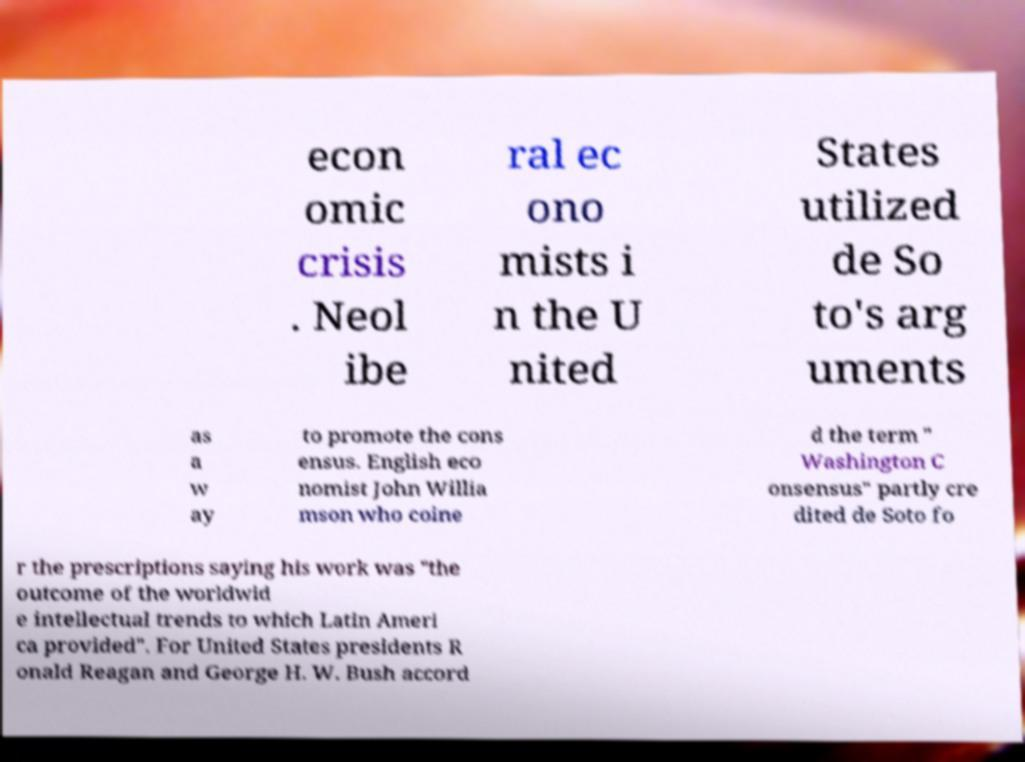Can you accurately transcribe the text from the provided image for me? econ omic crisis . Neol ibe ral ec ono mists i n the U nited States utilized de So to's arg uments as a w ay to promote the cons ensus. English eco nomist John Willia mson who coine d the term " Washington C onsensus" partly cre dited de Soto fo r the prescriptions saying his work was "the outcome of the worldwid e intellectual trends to which Latin Ameri ca provided". For United States presidents R onald Reagan and George H. W. Bush accord 